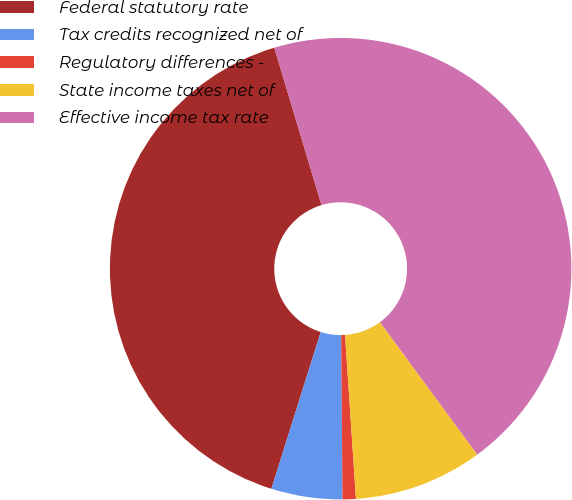Convert chart. <chart><loc_0><loc_0><loc_500><loc_500><pie_chart><fcel>Federal statutory rate<fcel>Tax credits recognized net of<fcel>Regulatory differences -<fcel>State income taxes net of<fcel>Effective income tax rate<nl><fcel>40.51%<fcel>4.98%<fcel>0.93%<fcel>9.03%<fcel>44.56%<nl></chart> 